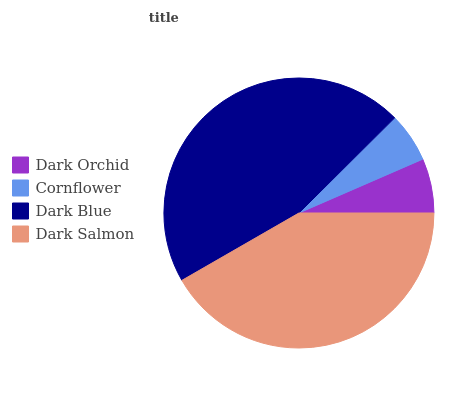Is Cornflower the minimum?
Answer yes or no. Yes. Is Dark Blue the maximum?
Answer yes or no. Yes. Is Dark Blue the minimum?
Answer yes or no. No. Is Cornflower the maximum?
Answer yes or no. No. Is Dark Blue greater than Cornflower?
Answer yes or no. Yes. Is Cornflower less than Dark Blue?
Answer yes or no. Yes. Is Cornflower greater than Dark Blue?
Answer yes or no. No. Is Dark Blue less than Cornflower?
Answer yes or no. No. Is Dark Salmon the high median?
Answer yes or no. Yes. Is Dark Orchid the low median?
Answer yes or no. Yes. Is Cornflower the high median?
Answer yes or no. No. Is Dark Salmon the low median?
Answer yes or no. No. 